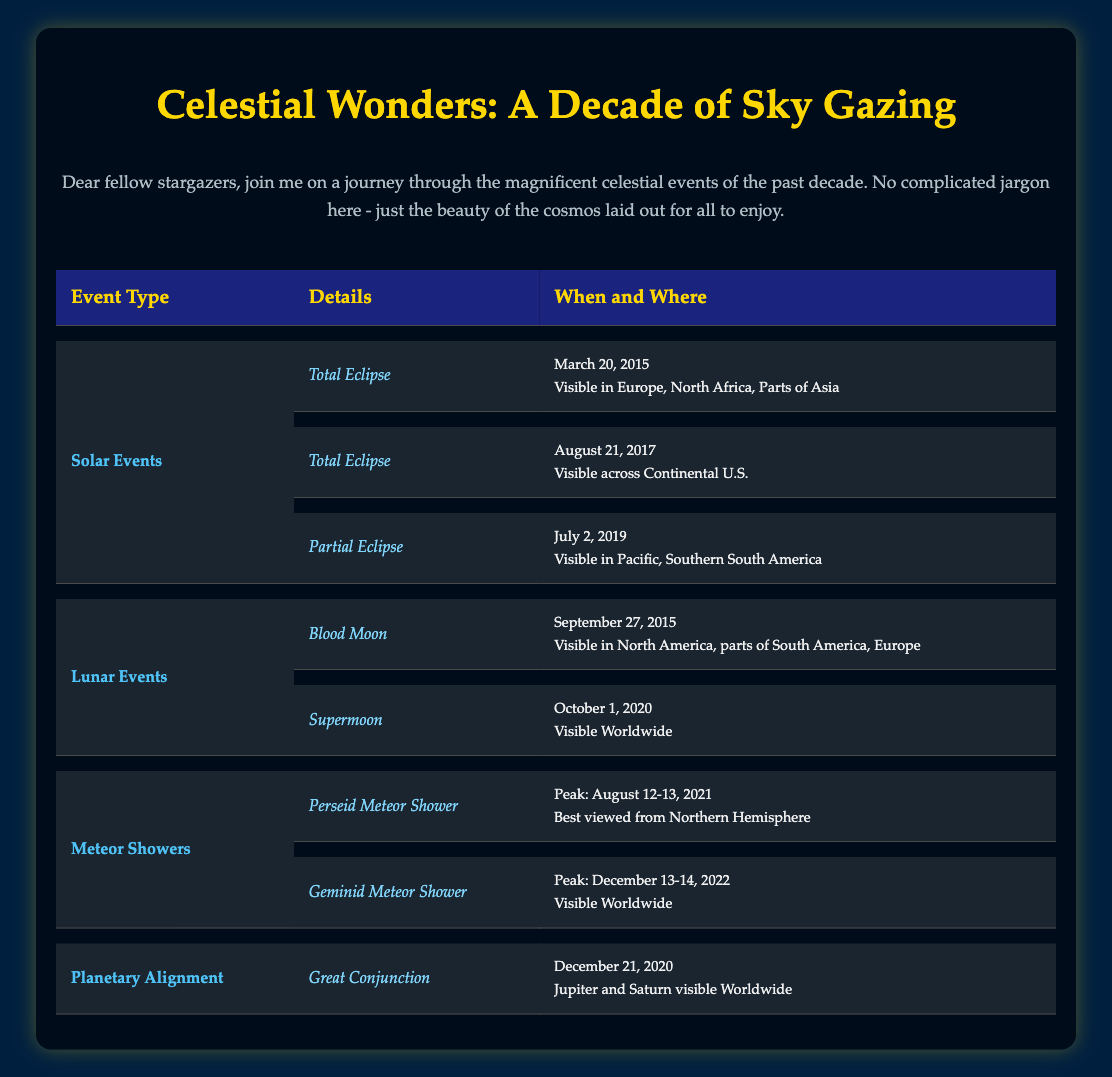What types of solar eclipses occurred in the last decade? The table lists two types of solar eclipses: Total Solar Eclipse and Partial Solar Eclipse. The Total Solar Eclipses occurred on March 20, 2015, and August 21, 2017, while the Partial Solar Eclipse occurred on July 2, 2019.
Answer: Total Solar Eclipse, Partial Solar Eclipse Which celestial event was visible worldwide in 2020? The table indicates that the Supermoon on October 1, 2020, and the Great Conjunction on December 21, 2020, were both visible worldwide.
Answer: Supermoon, Great Conjunction How many lunar events were recorded? There were two lunar events listed: one Blood Moon in 2015 and one Supermoon in 2020, totaling two lunar events in the decade.
Answer: 2 Did any partial solar eclipses occur in 2021? The table does not list any partial solar eclipses specifically for the year 2021, indicating that none were recorded in that year.
Answer: No What was the peak date for the Geminid Meteor Shower? According to the table, the peak date for the Geminid Meteor Shower was December 13-14, 2022, as stated in the details section.
Answer: December 13-14, 2022 Which event had the widest visibility? To determine which event had the widest visibility, we compare the visibility sections. The Supermoon on October 1, 2020, is described as being visible worldwide, the same as the Great Conjunction on December 21, 2020. Since both events have the same visibility, we conclude that they are tied for the widest visibility.
Answer: Supermoon, Great Conjunction How many meteor shower events are listed in the last decade? The table lists two meteor shower events: the Perseid Meteor Shower in 2021 and the Geminid Meteor Shower in 2022. Therefore, there are two recorded meteor shower events over the last decade.
Answer: 2 What is the date of the Blood Moon event? Referring to the table, the Blood Moon event took place on September 27, 2015, as listed in the date section.
Answer: September 27, 2015 Was there any solar eclipse visible in 2019? Yes, the Partial Solar Eclipse occurred on July 2, 2019, and it is mentioned in the solar events section of the table.
Answer: Yes 